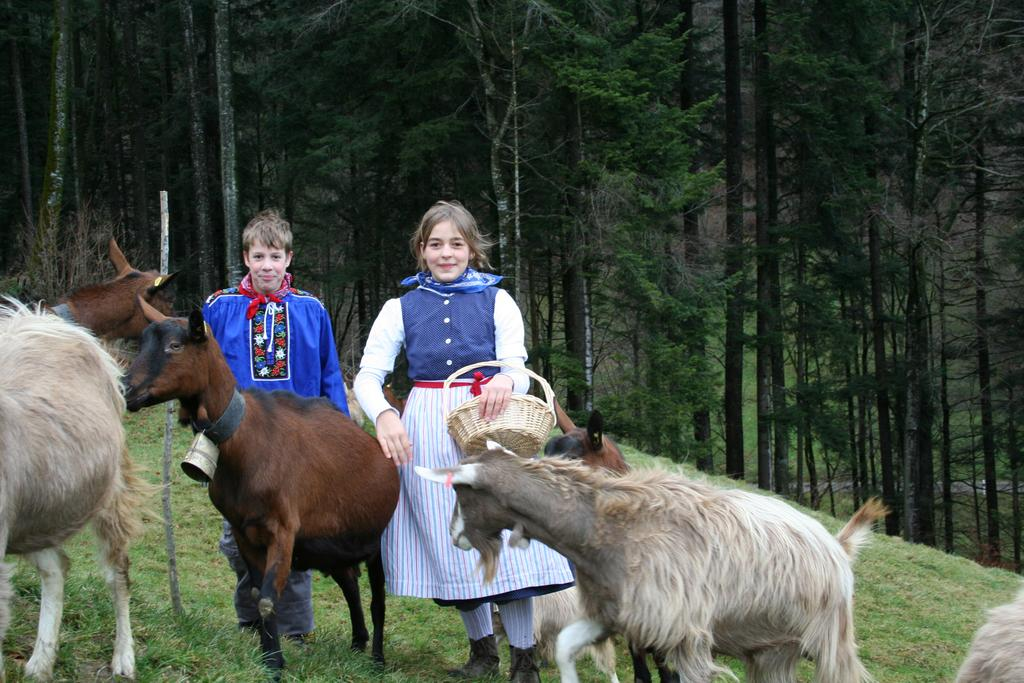Who are the people in the image? There is a boy and a girl in the image. What animals are present in the image? There are goats in the image. What are the goats doing in the image? The goats are walking on the grass ground. What can be seen in the background of the image? There are trees visible in the background of the image. What type of grain is being used as bait for the goats in the image? There is no grain or bait present in the image; the goats are simply walking on the grass ground. 